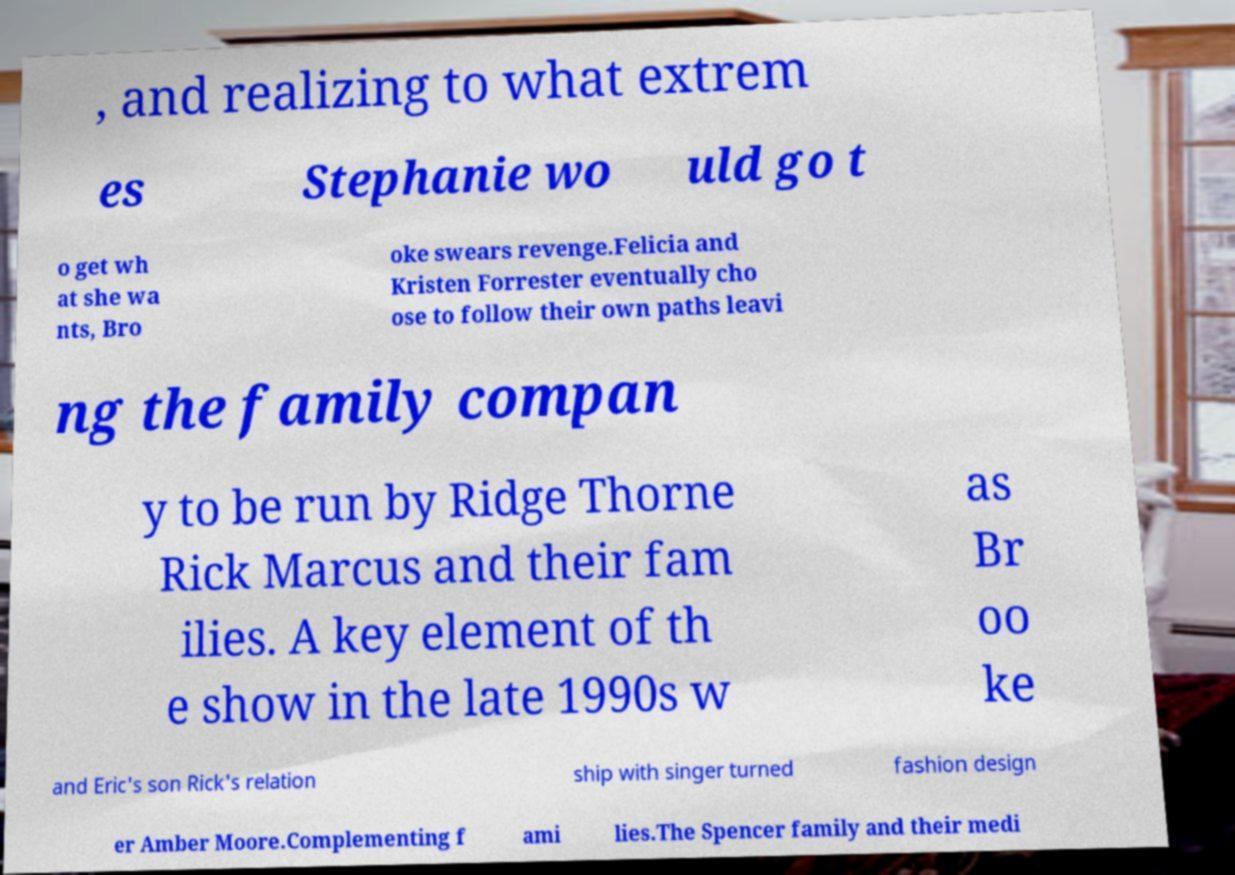There's text embedded in this image that I need extracted. Can you transcribe it verbatim? , and realizing to what extrem es Stephanie wo uld go t o get wh at she wa nts, Bro oke swears revenge.Felicia and Kristen Forrester eventually cho ose to follow their own paths leavi ng the family compan y to be run by Ridge Thorne Rick Marcus and their fam ilies. A key element of th e show in the late 1990s w as Br oo ke and Eric's son Rick's relation ship with singer turned fashion design er Amber Moore.Complementing f ami lies.The Spencer family and their medi 